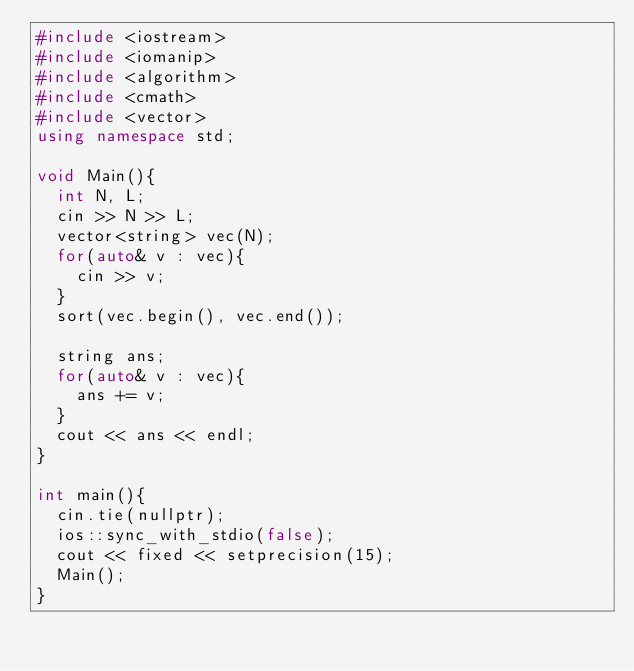Convert code to text. <code><loc_0><loc_0><loc_500><loc_500><_C++_>#include <iostream>
#include <iomanip>
#include <algorithm>
#include <cmath>
#include <vector>
using namespace std;

void Main(){
  int N, L;
  cin >> N >> L;
  vector<string> vec(N);
  for(auto& v : vec){
    cin >> v;
  }
  sort(vec.begin(), vec.end());

  string ans;
  for(auto& v : vec){
    ans += v;
  }
  cout << ans << endl;
}

int main(){
  cin.tie(nullptr);
  ios::sync_with_stdio(false);
  cout << fixed << setprecision(15);
  Main();
}</code> 